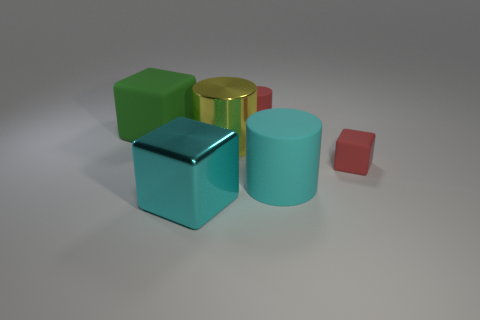Subtract 1 cylinders. How many cylinders are left? 2 Add 2 rubber things. How many objects exist? 8 Add 1 large yellow objects. How many large yellow objects exist? 2 Subtract 1 green blocks. How many objects are left? 5 Subtract all tiny blue matte cubes. Subtract all green matte things. How many objects are left? 5 Add 4 green rubber objects. How many green rubber objects are left? 5 